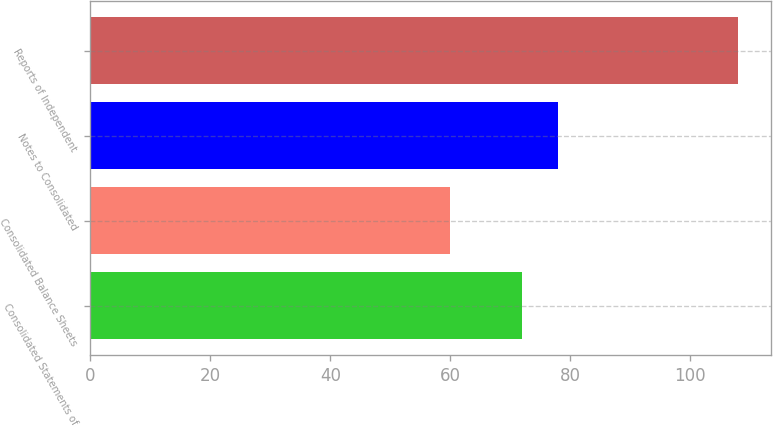Convert chart. <chart><loc_0><loc_0><loc_500><loc_500><bar_chart><fcel>Consolidated Statements of<fcel>Consolidated Balance Sheets<fcel>Notes to Consolidated<fcel>Reports of Independent<nl><fcel>72<fcel>60<fcel>78<fcel>108<nl></chart> 